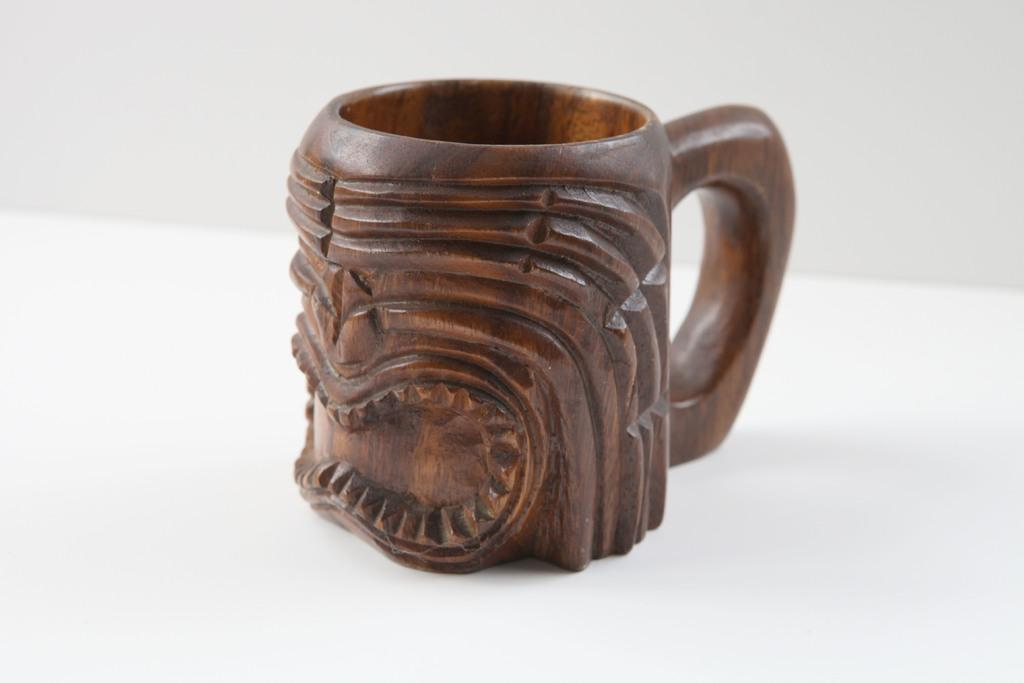What material is the cap made of in the image? The cap is made of wood. How does the ant contribute to the pollution in the image? There is no ant or pollution present in the image; it only features a wooden cap. 